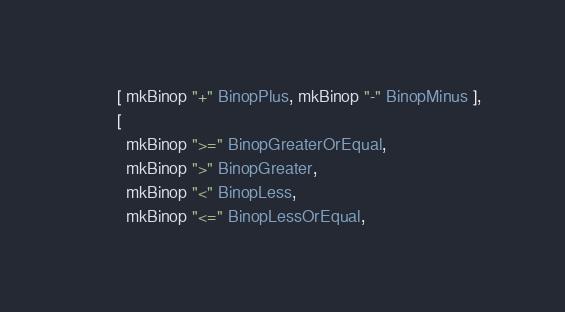Convert code to text. <code><loc_0><loc_0><loc_500><loc_500><_Haskell_>       [ mkBinop "+" BinopPlus, mkBinop "-" BinopMinus ],
       [
         mkBinop ">=" BinopGreaterOrEqual,
         mkBinop ">" BinopGreater,
         mkBinop "<" BinopLess,
         mkBinop "<=" BinopLessOrEqual,</code> 